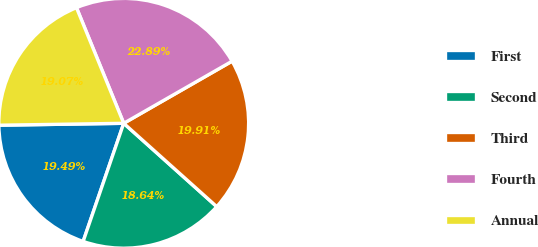Convert chart to OTSL. <chart><loc_0><loc_0><loc_500><loc_500><pie_chart><fcel>First<fcel>Second<fcel>Third<fcel>Fourth<fcel>Annual<nl><fcel>19.49%<fcel>18.64%<fcel>19.91%<fcel>22.89%<fcel>19.07%<nl></chart> 